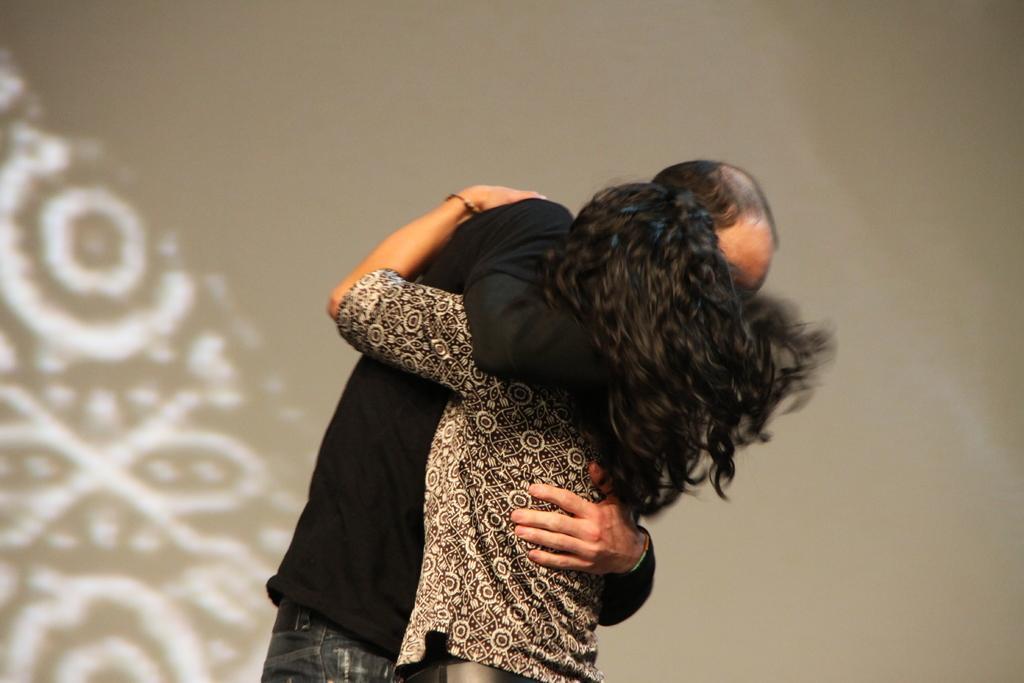Describe this image in one or two sentences. In this image there are two persons standing and hugging each other , and in the background there is a wall. 